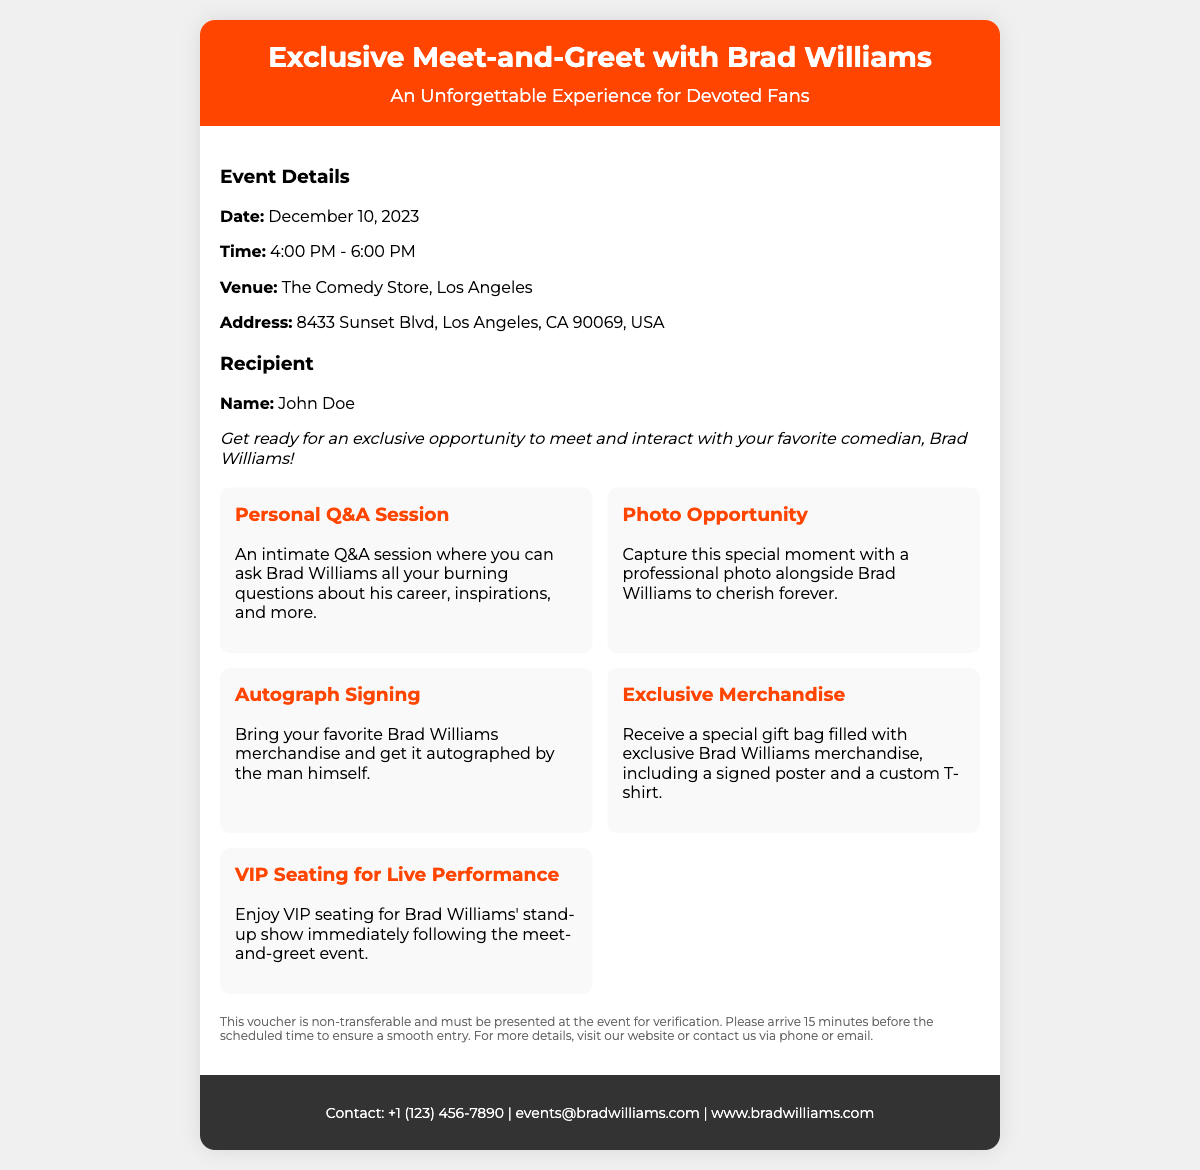What is the date of the event? The date of the event is specified in the document's event details section.
Answer: December 10, 2023 What time does the meet-and-greet start? The starting time is indicated as part of the event details.
Answer: 4:00 PM Where is the venue located? The venue information is listed in the event details, including the name and address.
Answer: The Comedy Store, Los Angeles What is included in the exclusive merchandise? The exclusive merchandise details can be found in the list of activities included with the voucher.
Answer: Signed poster and a custom T-shirt Who is the recipient of the voucher? The recipient's name is clearly stated in the recipient details.
Answer: John Doe What type of session can fans participate in? The type of session available for fans to engage in is mentioned in the activities section.
Answer: Personal Q&A Session What is required to access the event? The requirements for attending the event is provided in the terms section of the document.
Answer: Present this voucher What should attendees do before the event starts? Instructions regarding attendee preparation are given in the terms section.
Answer: Arrive 15 minutes before the scheduled time What kind of seating will attendees enjoy? The type of seating for the performance is described in the activities section.
Answer: VIP Seating for Live Performance 